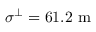Convert formula to latex. <formula><loc_0><loc_0><loc_500><loc_500>\sigma ^ { \perp } = 6 1 . 2 m</formula> 